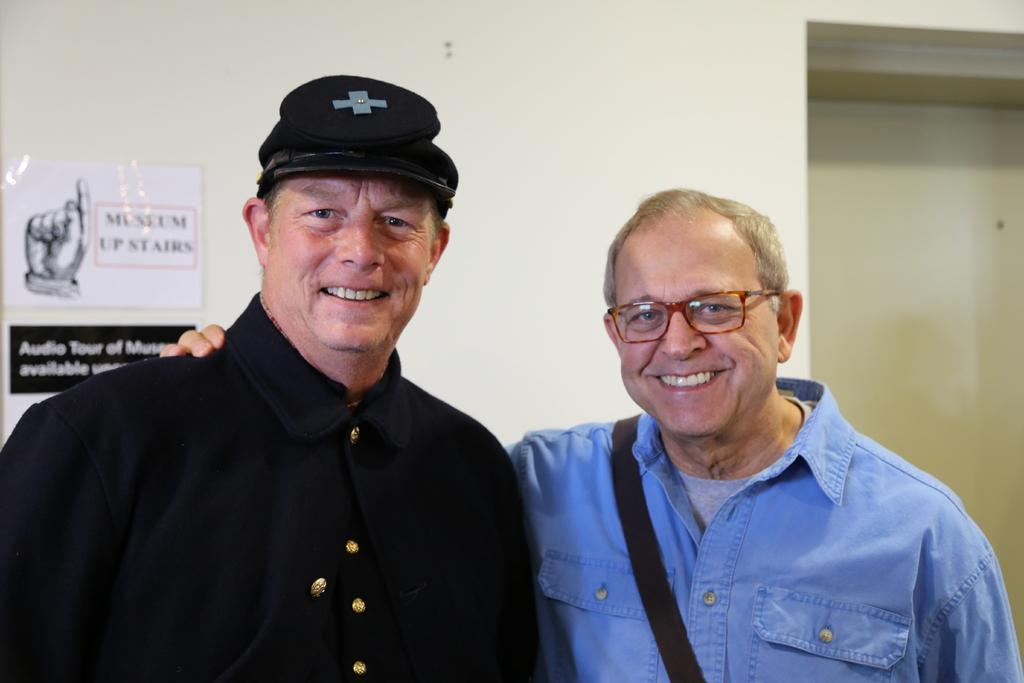How many people are in the image? There are two people in the image. What are the people doing in the image? The people are standing and smiling. What can be seen in the background of the image? There is a wall in the background of the image. What is on the wall in the image? There is a poster and a board on the wall. What type of creature is depicted on the board in the image? There is no creature depicted on the board in the image; it is a board with no visible images or text. 